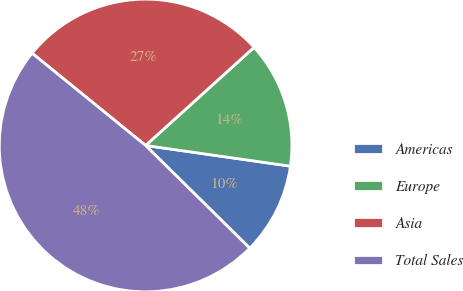Convert chart. <chart><loc_0><loc_0><loc_500><loc_500><pie_chart><fcel>Americas<fcel>Europe<fcel>Asia<fcel>Total Sales<nl><fcel>10.13%<fcel>13.96%<fcel>27.43%<fcel>48.47%<nl></chart> 